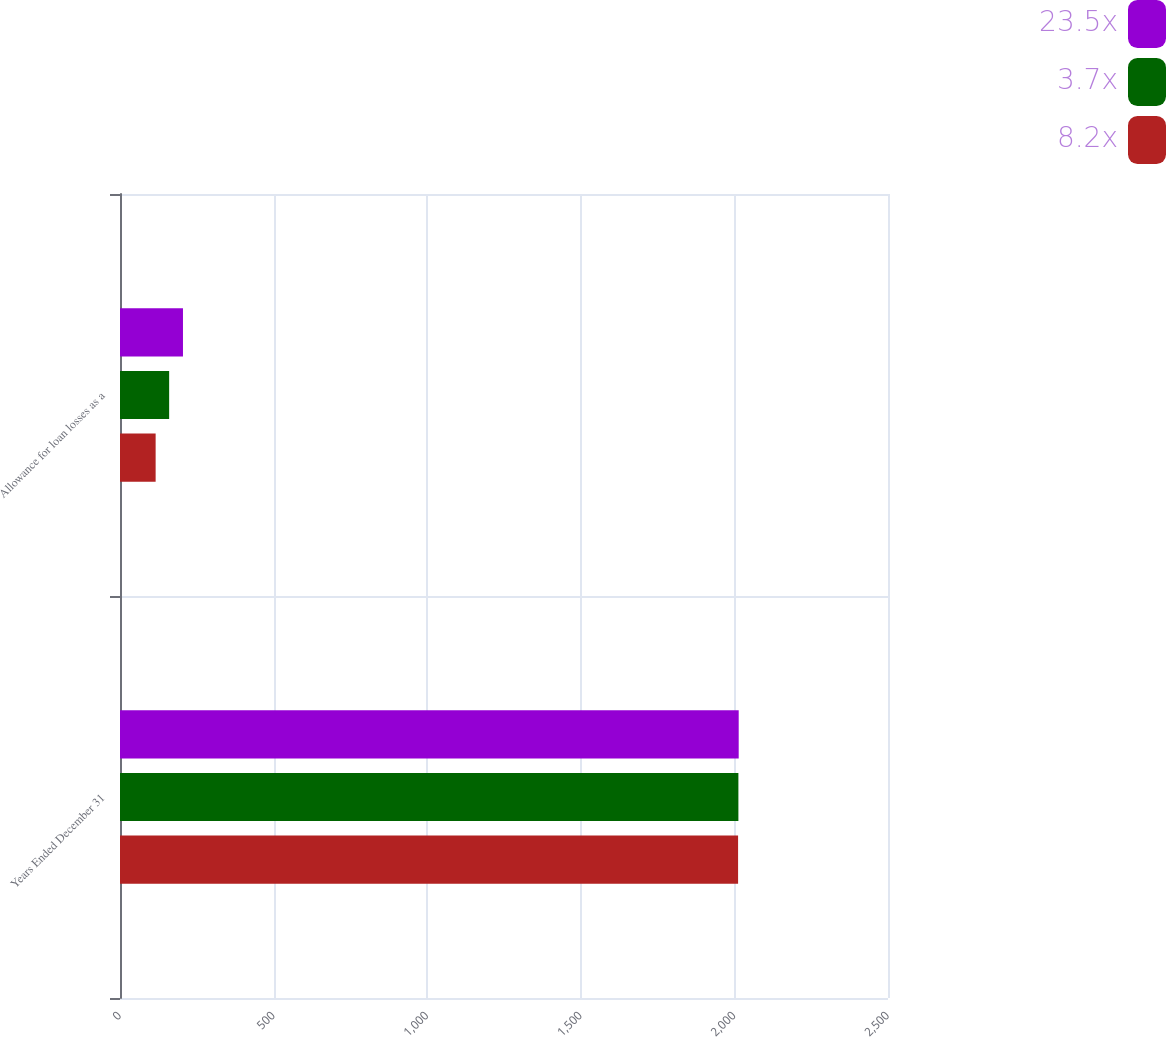Convert chart to OTSL. <chart><loc_0><loc_0><loc_500><loc_500><stacked_bar_chart><ecel><fcel>Years Ended December 31<fcel>Allowance for loan losses as a<nl><fcel>23.5x<fcel>2014<fcel>205<nl><fcel>3.7x<fcel>2013<fcel>160<nl><fcel>8.2x<fcel>2012<fcel>116<nl></chart> 